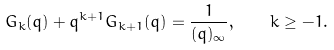Convert formula to latex. <formula><loc_0><loc_0><loc_500><loc_500>G _ { k } ( q ) + q ^ { k + 1 } G _ { k + 1 } ( q ) = \frac { 1 } { ( q ) _ { \infty } } , \quad k \geq - 1 .</formula> 